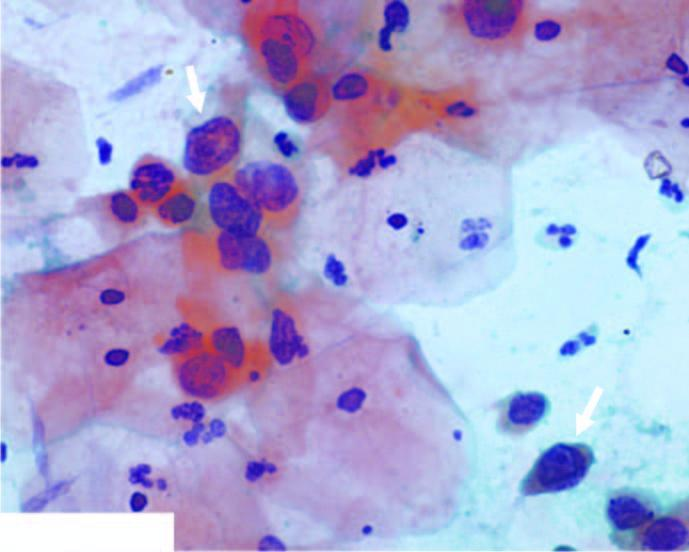did miliary have irregular nuclear outlines?
Answer the question using a single word or phrase. No 